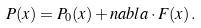Convert formula to latex. <formula><loc_0><loc_0><loc_500><loc_500>P ( x ) = P _ { 0 } ( x ) + n a b l a \cdot F ( x ) \, .</formula> 